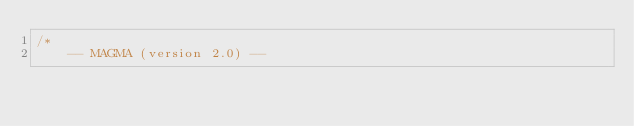<code> <loc_0><loc_0><loc_500><loc_500><_Cuda_>/*
    -- MAGMA (version 2.0) --</code> 